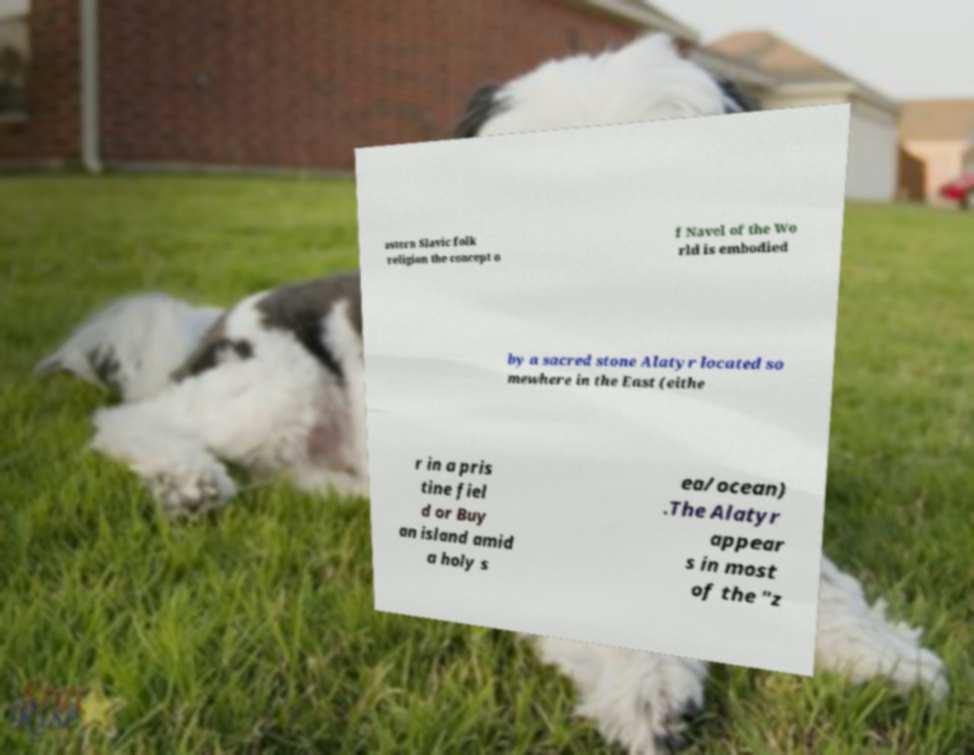Can you read and provide the text displayed in the image?This photo seems to have some interesting text. Can you extract and type it out for me? astern Slavic folk religion the concept o f Navel of the Wo rld is embodied by a sacred stone Alatyr located so mewhere in the East (eithe r in a pris tine fiel d or Buy an island amid a holy s ea/ocean) .The Alatyr appear s in most of the "z 